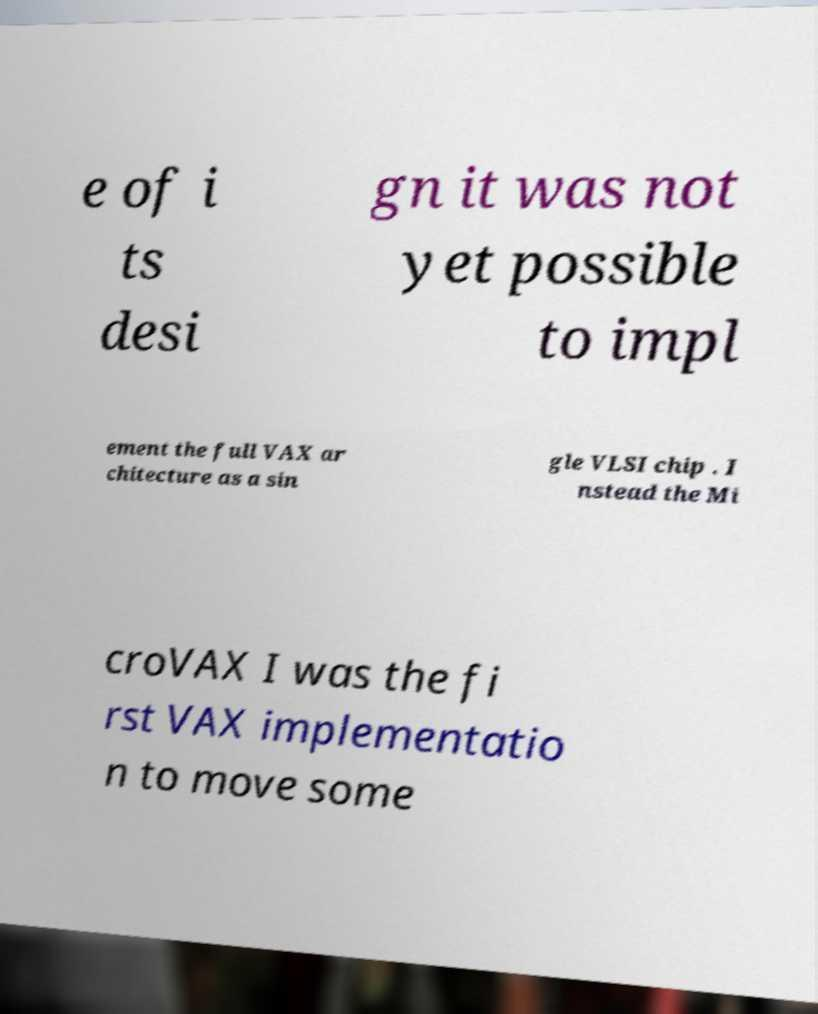Can you read and provide the text displayed in the image?This photo seems to have some interesting text. Can you extract and type it out for me? e of i ts desi gn it was not yet possible to impl ement the full VAX ar chitecture as a sin gle VLSI chip . I nstead the Mi croVAX I was the fi rst VAX implementatio n to move some 